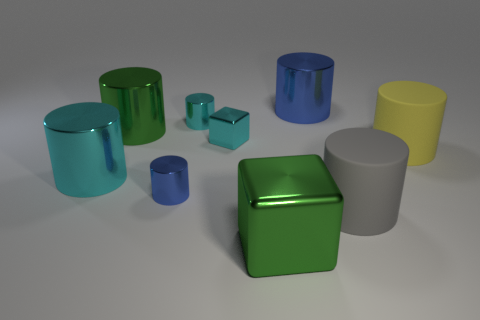Subtract all small cyan shiny cylinders. How many cylinders are left? 6 Subtract all blue cylinders. How many cylinders are left? 5 Add 1 large green objects. How many objects exist? 10 Subtract all blue cylinders. Subtract all yellow spheres. How many cylinders are left? 5 Add 8 large cyan cylinders. How many large cyan cylinders exist? 9 Subtract 0 blue balls. How many objects are left? 9 Subtract all cylinders. How many objects are left? 2 Subtract all tiny brown balls. Subtract all big blue metallic cylinders. How many objects are left? 8 Add 8 tiny blocks. How many tiny blocks are left? 9 